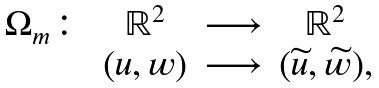Convert formula to latex. <formula><loc_0><loc_0><loc_500><loc_500>\begin{array} { c c c c } \Omega _ { m } \colon & \mathbb { R } ^ { 2 } & \longrightarrow & \mathbb { R } ^ { 2 } \\ & ( u , w ) & \longrightarrow & ( \widetilde { u } , \widetilde { w } ) \text {,} \end{array}</formula> 